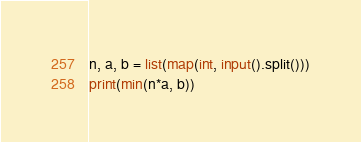Convert code to text. <code><loc_0><loc_0><loc_500><loc_500><_Python_>n, a, b = list(map(int, input().split()))
print(min(n*a, b))</code> 